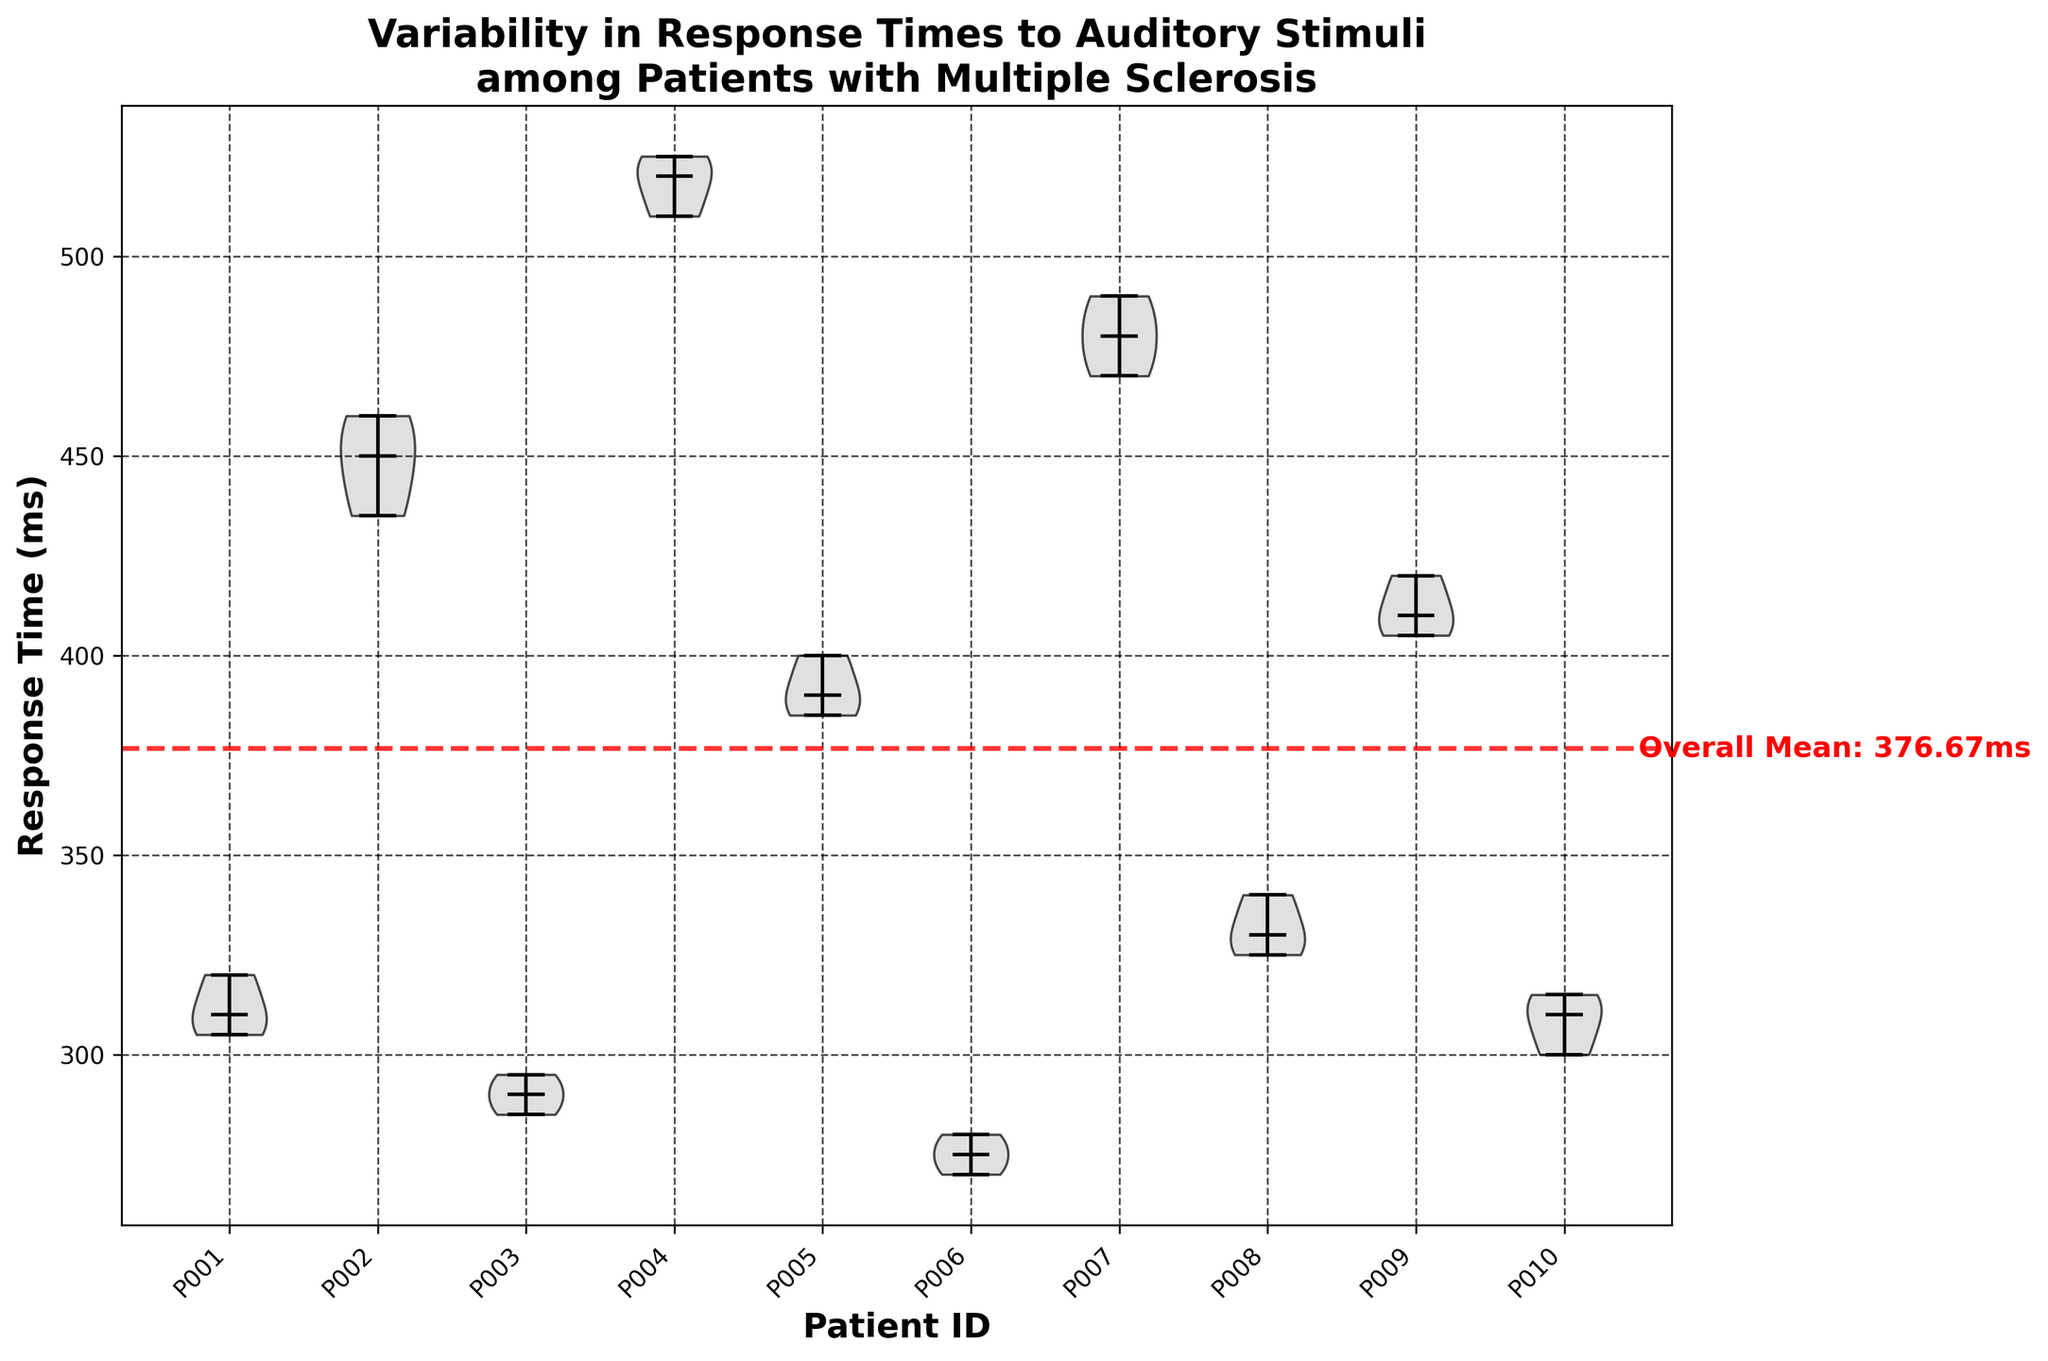How many patients are included in the study? The x-axis shows labels for each patient, starting from P001 to P010, indicating that there are 10 patients included in the study.
Answer: 10 What is the title of the chart? The title is positioned at the top of the chart in bold font.
Answer: Variability in Response Times to Auditory Stimuli among Patients with Multiple Sclerosis Which patient has the highest median response time? The median response time for each patient is shown by the black horizontal line within each violin plot. Patient P004 shows the highest median response time.
Answer: P004 What is the overall mean response time? The overall mean response time is represented by a red dashed horizontal line across the chart with text indicating its value.
Answer: 360.33 ms Which two patients have the closest median response times? By visually comparing the median lines, patients P003 and P010 have median lines that are very close to each other.
Answer: P003 and P010 Does any patient have all their response times above the overall mean? Patient P004's entire violin plot is above the red dashed line representing the overall mean. This indicates that all their response times are above the overall mean.
Answer: Yes, P004 Which patient has the lowest variability in response times? The width of the violin plot shows the distribution of response times. Patient P006 has the narrowest violin plot, indicating the lowest variability.
Answer: P006 What is the approximate range of response times for patient P002? The range of response times is indicated by the extent of the violin plot vertically. For patient P002, the response times range approximately between 435 ms and 460 ms.
Answer: 435 ms - 460 ms Are there more patients with median response times below or above 400 ms? By counting the patients with their median line below and above 400 ms, we find that 7 patients (P001, P003, P005, P006, P008, P009, P010) have medians below 400 ms, and 3 patients (P002, P004, P007) have medians above 400 ms.
Answer: Below Which patient exhibits the highest variability in their response times? The width and spread of the violin plot across the y-axis reflect variability. Patient P004 displays the widest spread, indicating the highest variability.
Answer: P004 